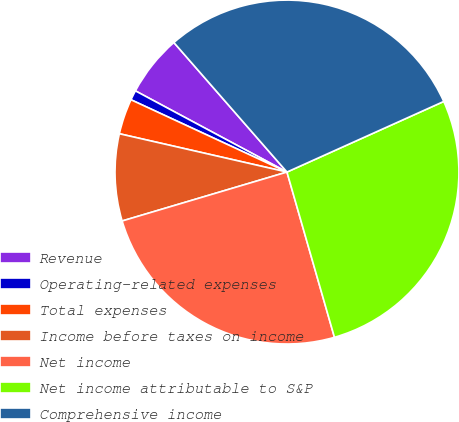<chart> <loc_0><loc_0><loc_500><loc_500><pie_chart><fcel>Revenue<fcel>Operating-related expenses<fcel>Total expenses<fcel>Income before taxes on income<fcel>Net income<fcel>Net income attributable to S&P<fcel>Comprehensive income<nl><fcel>5.75%<fcel>0.92%<fcel>3.33%<fcel>8.17%<fcel>24.86%<fcel>27.28%<fcel>29.69%<nl></chart> 